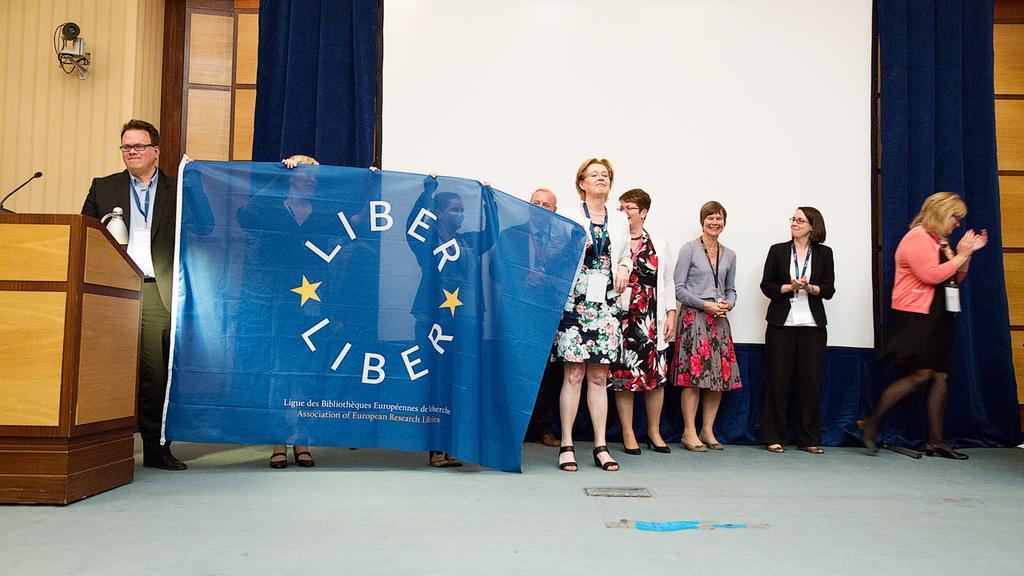Could you give a brief overview of what you see in this image? In this image we can see a group of people standing on the surface, some people are holding a flag with some text in their hands. On the left side of the image we can see a microphone and a lamp on a podium, we can also see a CCTV camera on the wall. At the top of the image we can see a screen and some curtains. 